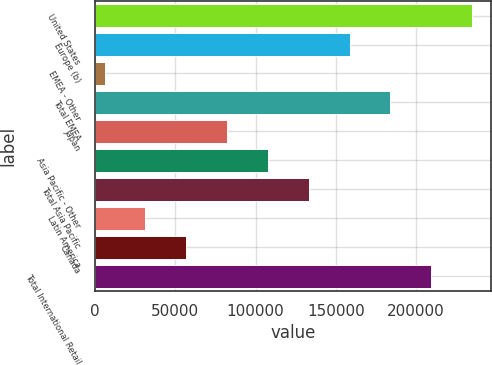<chart> <loc_0><loc_0><loc_500><loc_500><bar_chart><fcel>United States<fcel>Europe (b)<fcel>EMEA - Other<fcel>Total EMEA<fcel>Japan<fcel>Asia Pacific - Other<fcel>Total Asia Pacific<fcel>Latin America<fcel>Canada<fcel>Total International Retail<nl><fcel>234850<fcel>158532<fcel>5896<fcel>183971<fcel>82213.9<fcel>107653<fcel>133092<fcel>31335.3<fcel>56774.6<fcel>209410<nl></chart> 